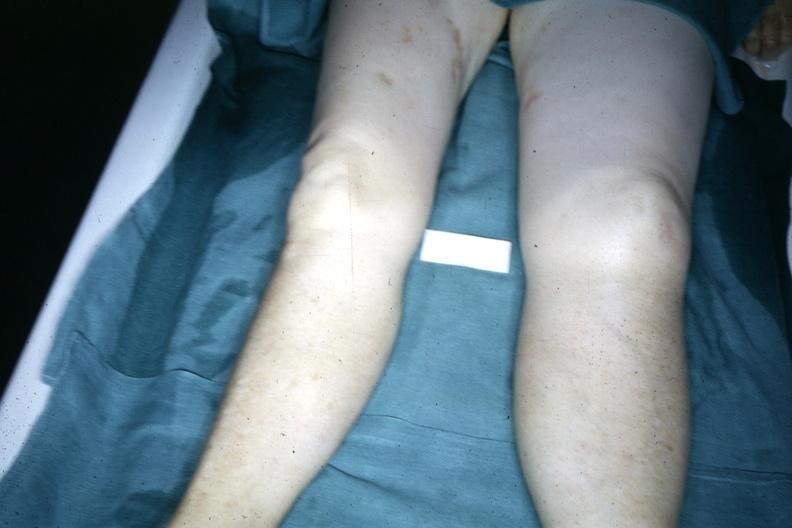does this image show?
Answer the question using a single word or phrase. Yes 